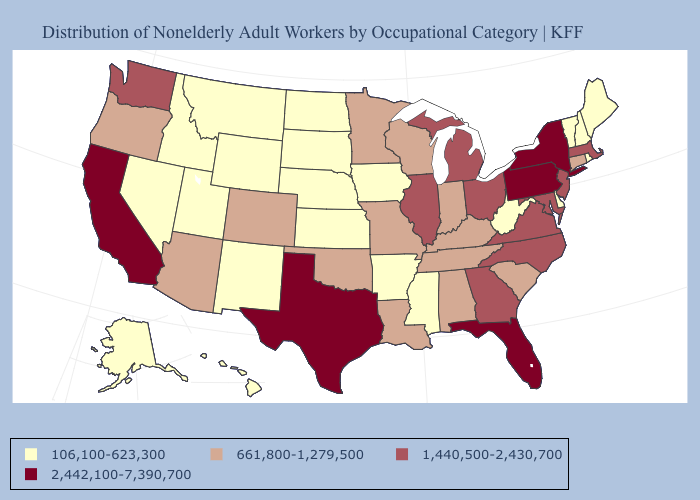Among the states that border Delaware , which have the highest value?
Short answer required. Pennsylvania. Which states have the lowest value in the Northeast?
Concise answer only. Maine, New Hampshire, Rhode Island, Vermont. Among the states that border Virginia , which have the highest value?
Give a very brief answer. Maryland, North Carolina. Does Louisiana have the lowest value in the South?
Quick response, please. No. What is the highest value in the USA?
Give a very brief answer. 2,442,100-7,390,700. Among the states that border Nebraska , does Colorado have the highest value?
Answer briefly. Yes. What is the value of Nevada?
Be succinct. 106,100-623,300. Which states have the highest value in the USA?
Short answer required. California, Florida, New York, Pennsylvania, Texas. What is the value of Minnesota?
Concise answer only. 661,800-1,279,500. Does the first symbol in the legend represent the smallest category?
Write a very short answer. Yes. What is the value of Washington?
Short answer required. 1,440,500-2,430,700. What is the value of Colorado?
Write a very short answer. 661,800-1,279,500. Name the states that have a value in the range 1,440,500-2,430,700?
Keep it brief. Georgia, Illinois, Maryland, Massachusetts, Michigan, New Jersey, North Carolina, Ohio, Virginia, Washington. What is the lowest value in the USA?
Short answer required. 106,100-623,300. Which states hav the highest value in the MidWest?
Concise answer only. Illinois, Michigan, Ohio. 